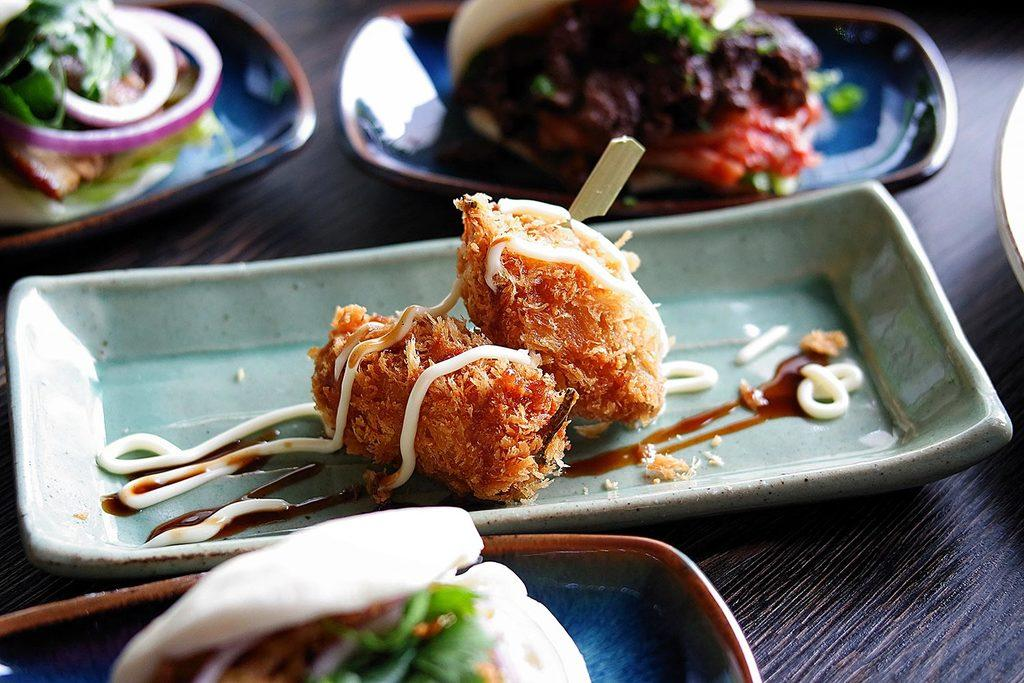What objects are placed on the table in the image? There are bowls placed on the table in the image. What is inside the bowls? Different food items are present in the bowls. What season is depicted in the image? The image does not depict a specific season; it only shows bowls with food items. How many brothers can be seen eating the food in the image? There are no people, including brothers, present in the image. 